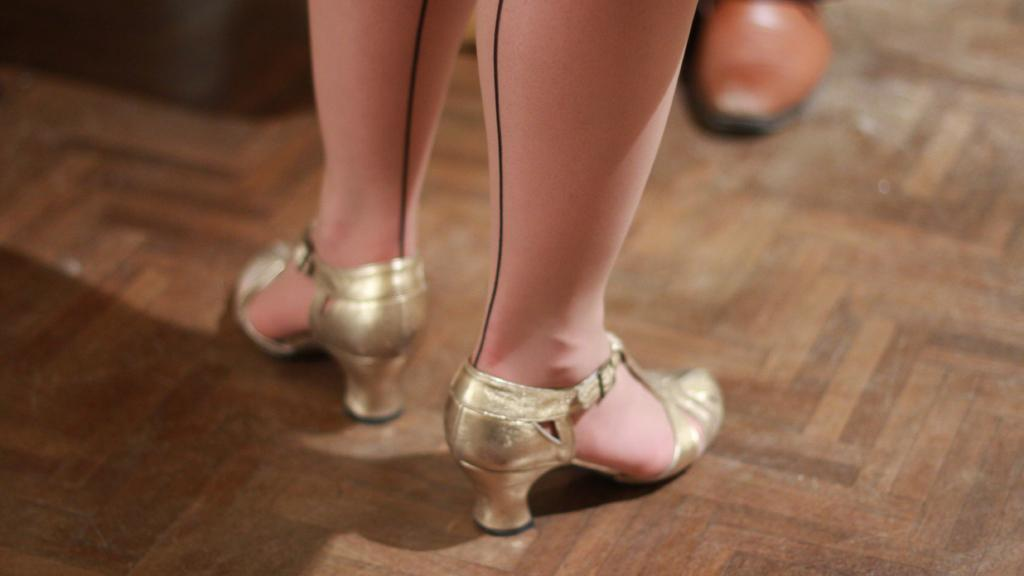What is the main focus of the image? The main focus of the image is women's legs with heels. What can be seen at the bottom of the image? There is a floor visible at the bottom of the image. Are there any other shoes visible in the image? Yes, there is a person's shoe in the background of the image. What type of bomb can be seen in the image? There is no bomb present in the image. Can you describe the bone structure of the legs in the image? The image does not show the bone structure of the legs; it only shows the women's legs with heels. 